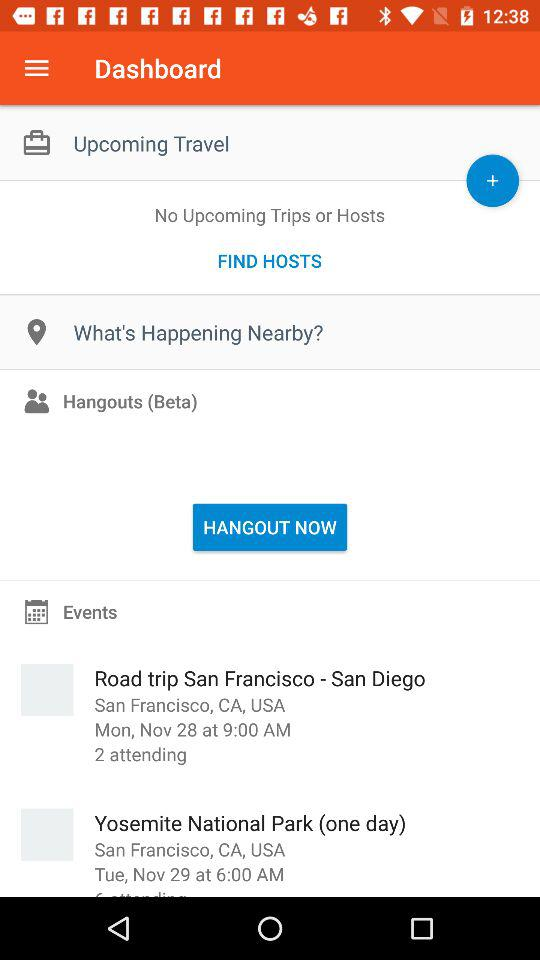How many people are attending the Road trip San Francisco - San Diego event?
Answer the question using a single word or phrase. 2 